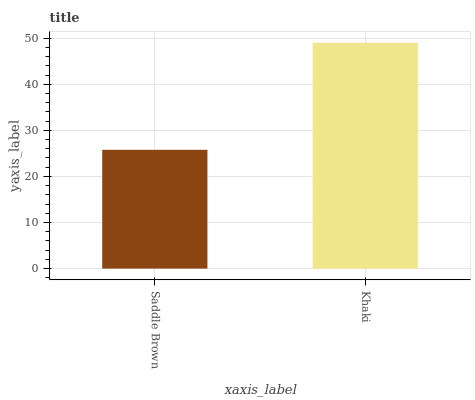Is Saddle Brown the minimum?
Answer yes or no. Yes. Is Khaki the maximum?
Answer yes or no. Yes. Is Khaki the minimum?
Answer yes or no. No. Is Khaki greater than Saddle Brown?
Answer yes or no. Yes. Is Saddle Brown less than Khaki?
Answer yes or no. Yes. Is Saddle Brown greater than Khaki?
Answer yes or no. No. Is Khaki less than Saddle Brown?
Answer yes or no. No. Is Khaki the high median?
Answer yes or no. Yes. Is Saddle Brown the low median?
Answer yes or no. Yes. Is Saddle Brown the high median?
Answer yes or no. No. Is Khaki the low median?
Answer yes or no. No. 